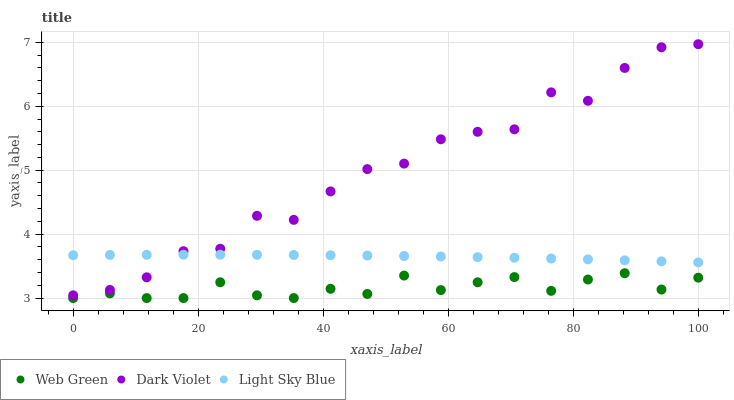Does Web Green have the minimum area under the curve?
Answer yes or no. Yes. Does Dark Violet have the maximum area under the curve?
Answer yes or no. Yes. Does Dark Violet have the minimum area under the curve?
Answer yes or no. No. Does Web Green have the maximum area under the curve?
Answer yes or no. No. Is Light Sky Blue the smoothest?
Answer yes or no. Yes. Is Dark Violet the roughest?
Answer yes or no. Yes. Is Web Green the smoothest?
Answer yes or no. No. Is Web Green the roughest?
Answer yes or no. No. Does Web Green have the lowest value?
Answer yes or no. Yes. Does Dark Violet have the lowest value?
Answer yes or no. No. Does Dark Violet have the highest value?
Answer yes or no. Yes. Does Web Green have the highest value?
Answer yes or no. No. Is Web Green less than Light Sky Blue?
Answer yes or no. Yes. Is Light Sky Blue greater than Web Green?
Answer yes or no. Yes. Does Dark Violet intersect Light Sky Blue?
Answer yes or no. Yes. Is Dark Violet less than Light Sky Blue?
Answer yes or no. No. Is Dark Violet greater than Light Sky Blue?
Answer yes or no. No. Does Web Green intersect Light Sky Blue?
Answer yes or no. No. 